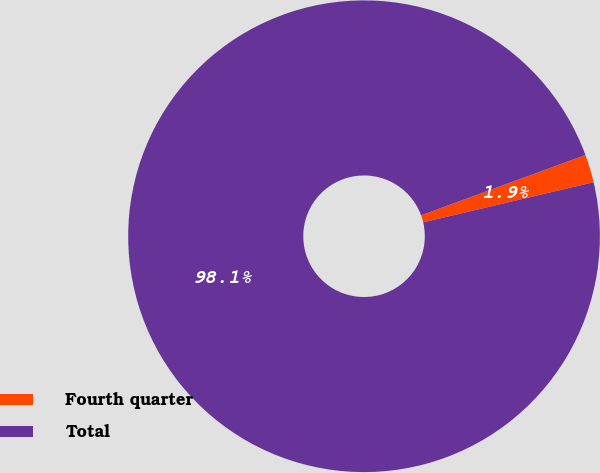<chart> <loc_0><loc_0><loc_500><loc_500><pie_chart><fcel>Fourth quarter<fcel>Total<nl><fcel>1.92%<fcel>98.08%<nl></chart> 